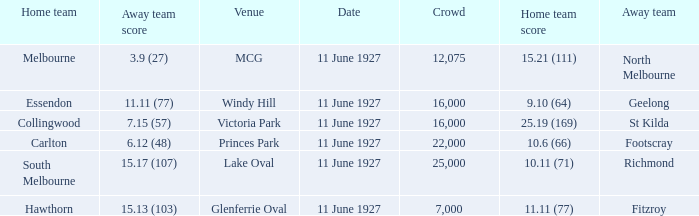How many people were in the crowd when Essendon was the home team? 1.0. 